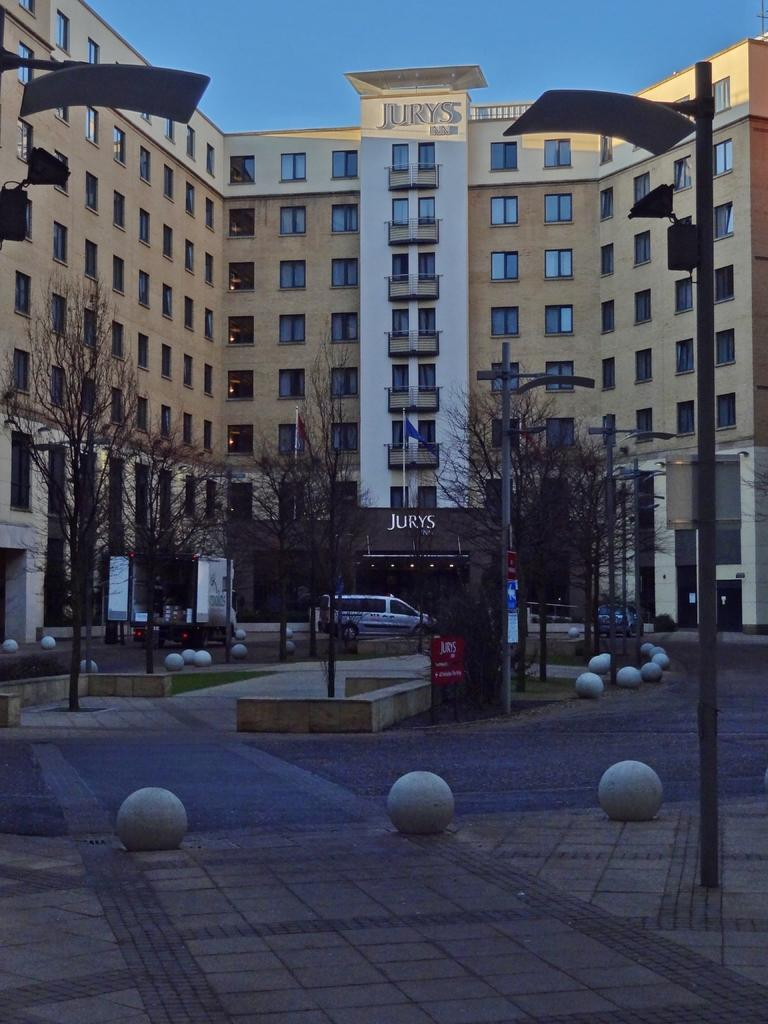What is the main feature of the image? There is a road in the image. What else can be seen along the road? There are poles, trees, a vehicle, boards, buildings, and a flag visible in the image. What is the color of the sky in the background? The sky is blue in the background. What type of zipper can be seen on the flag in the image? There is no zipper present on the flag in the image. What idea does the zebra in the image represent? There is no zebra present in the image, so it cannot represent any idea. 